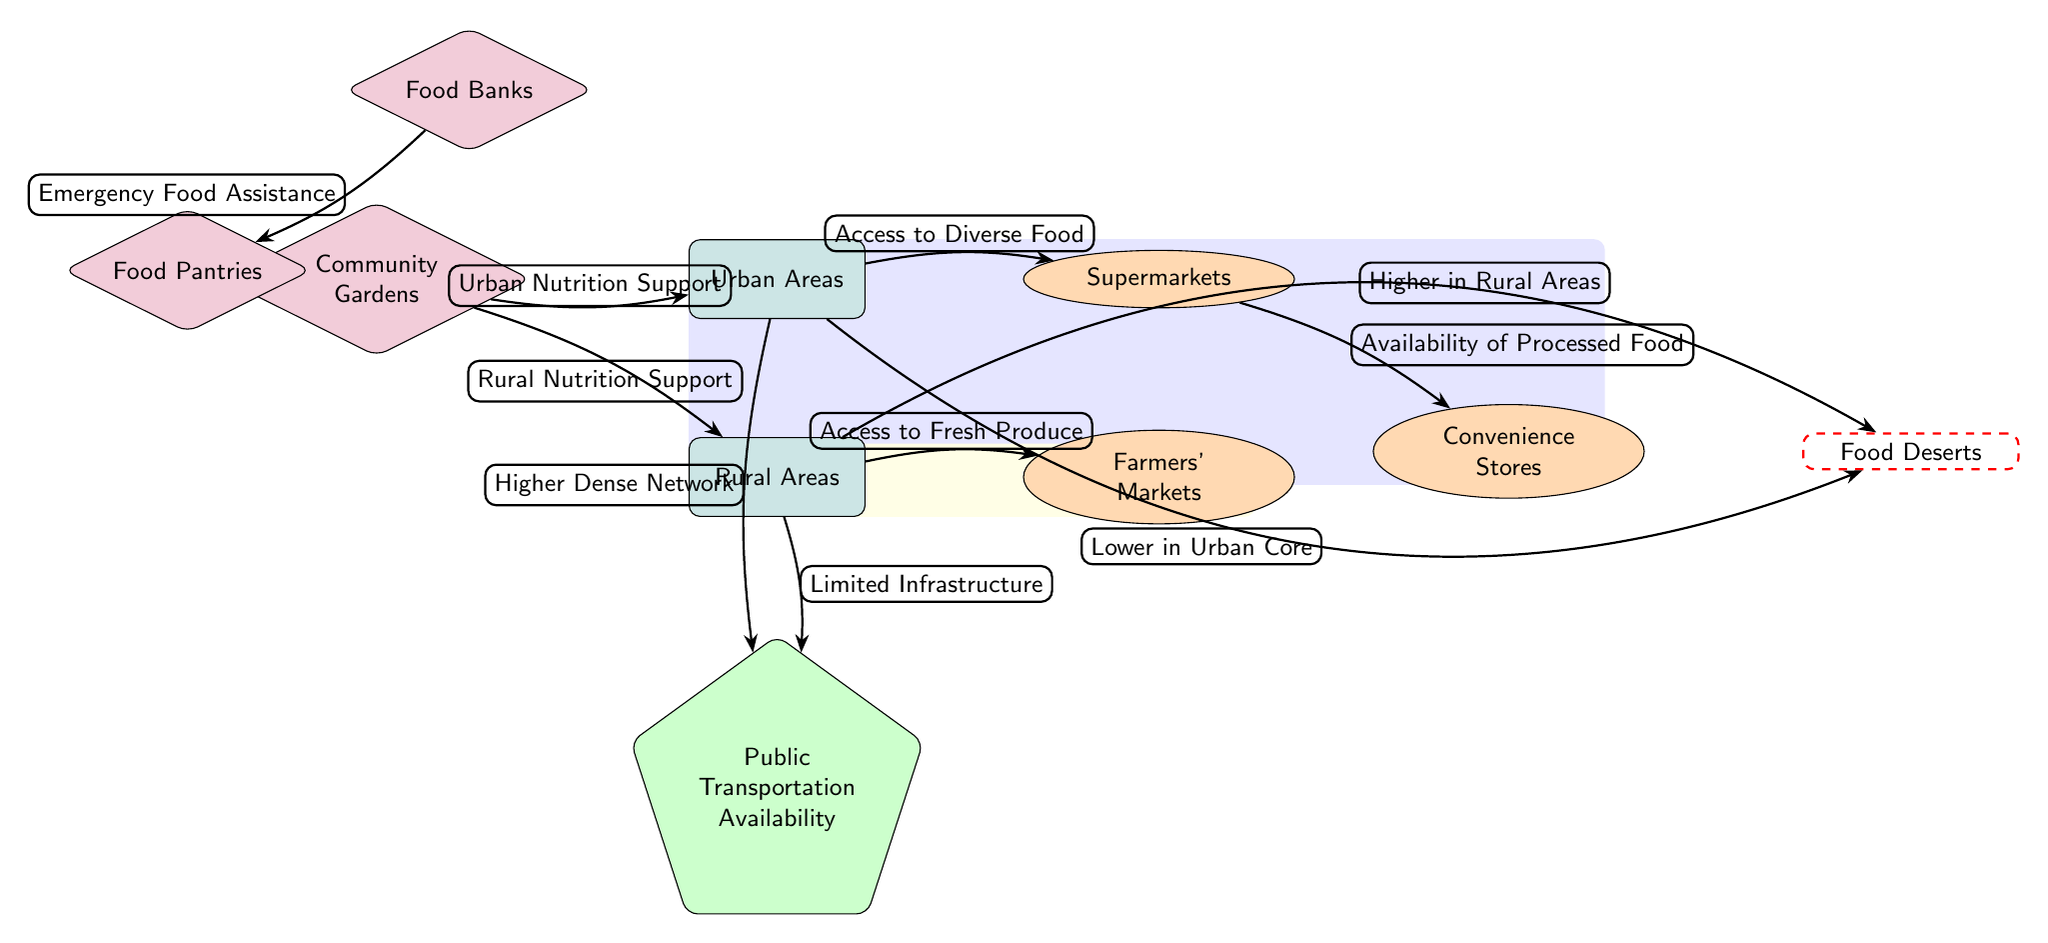What sources are available in urban areas? The diagram indicates that urban areas have access to Supermarkets, Community Gardens, Food Banks, Food Pantries, and Convenience Stores.
Answer: Supermarkets, Community Gardens, Food Banks, Food Pantries, Convenience Stores What type of transportation is shown impacting rural areas? The diagram includes "Public Transportation Availability" as a node indicating its effect on nutrition accessibility in rural areas.
Answer: Public Transportation Availability Which support source directly aids urban nutrition? Community Gardens are depicted as a direct support source for urban nutrition in the diagram.
Answer: Community Gardens How do food deserts compare in urban versus rural areas? The diagram shows that food deserts are lower in urban cores and higher in rural areas, indicating a geographical disparity in food availability.
Answer: Lower in Urban Core, Higher in Rural Areas What is the relationship between Food Banks and Food Pantries? The diagram shows a flow from Food Banks to Food Pantries, indicating that Food Banks provide emergency food assistance to Food Pantries.
Answer: Emergency Food Assistance Which source is exclusively related to providing fresh produce in rural areas? Farmers' Markets are exclusively depicted as a source providing access to fresh produce in rural areas.
Answer: Farmers' Markets How many support sources are shown for urban areas? The diagram lists three support sources for urban areas: Community Gardens, Food Banks, and Food Pantries.
Answer: Three What does the green node represent in rural areas? The diagram describes the green node as "Public Transportation Availability," representing its impact on access to nutritional food sources.
Answer: Public Transportation Availability Which area has a higher dense network? The diagram indicates that urban areas have a "Higher Dense Network" for food access compared to rural areas.
Answer: Urban Areas 